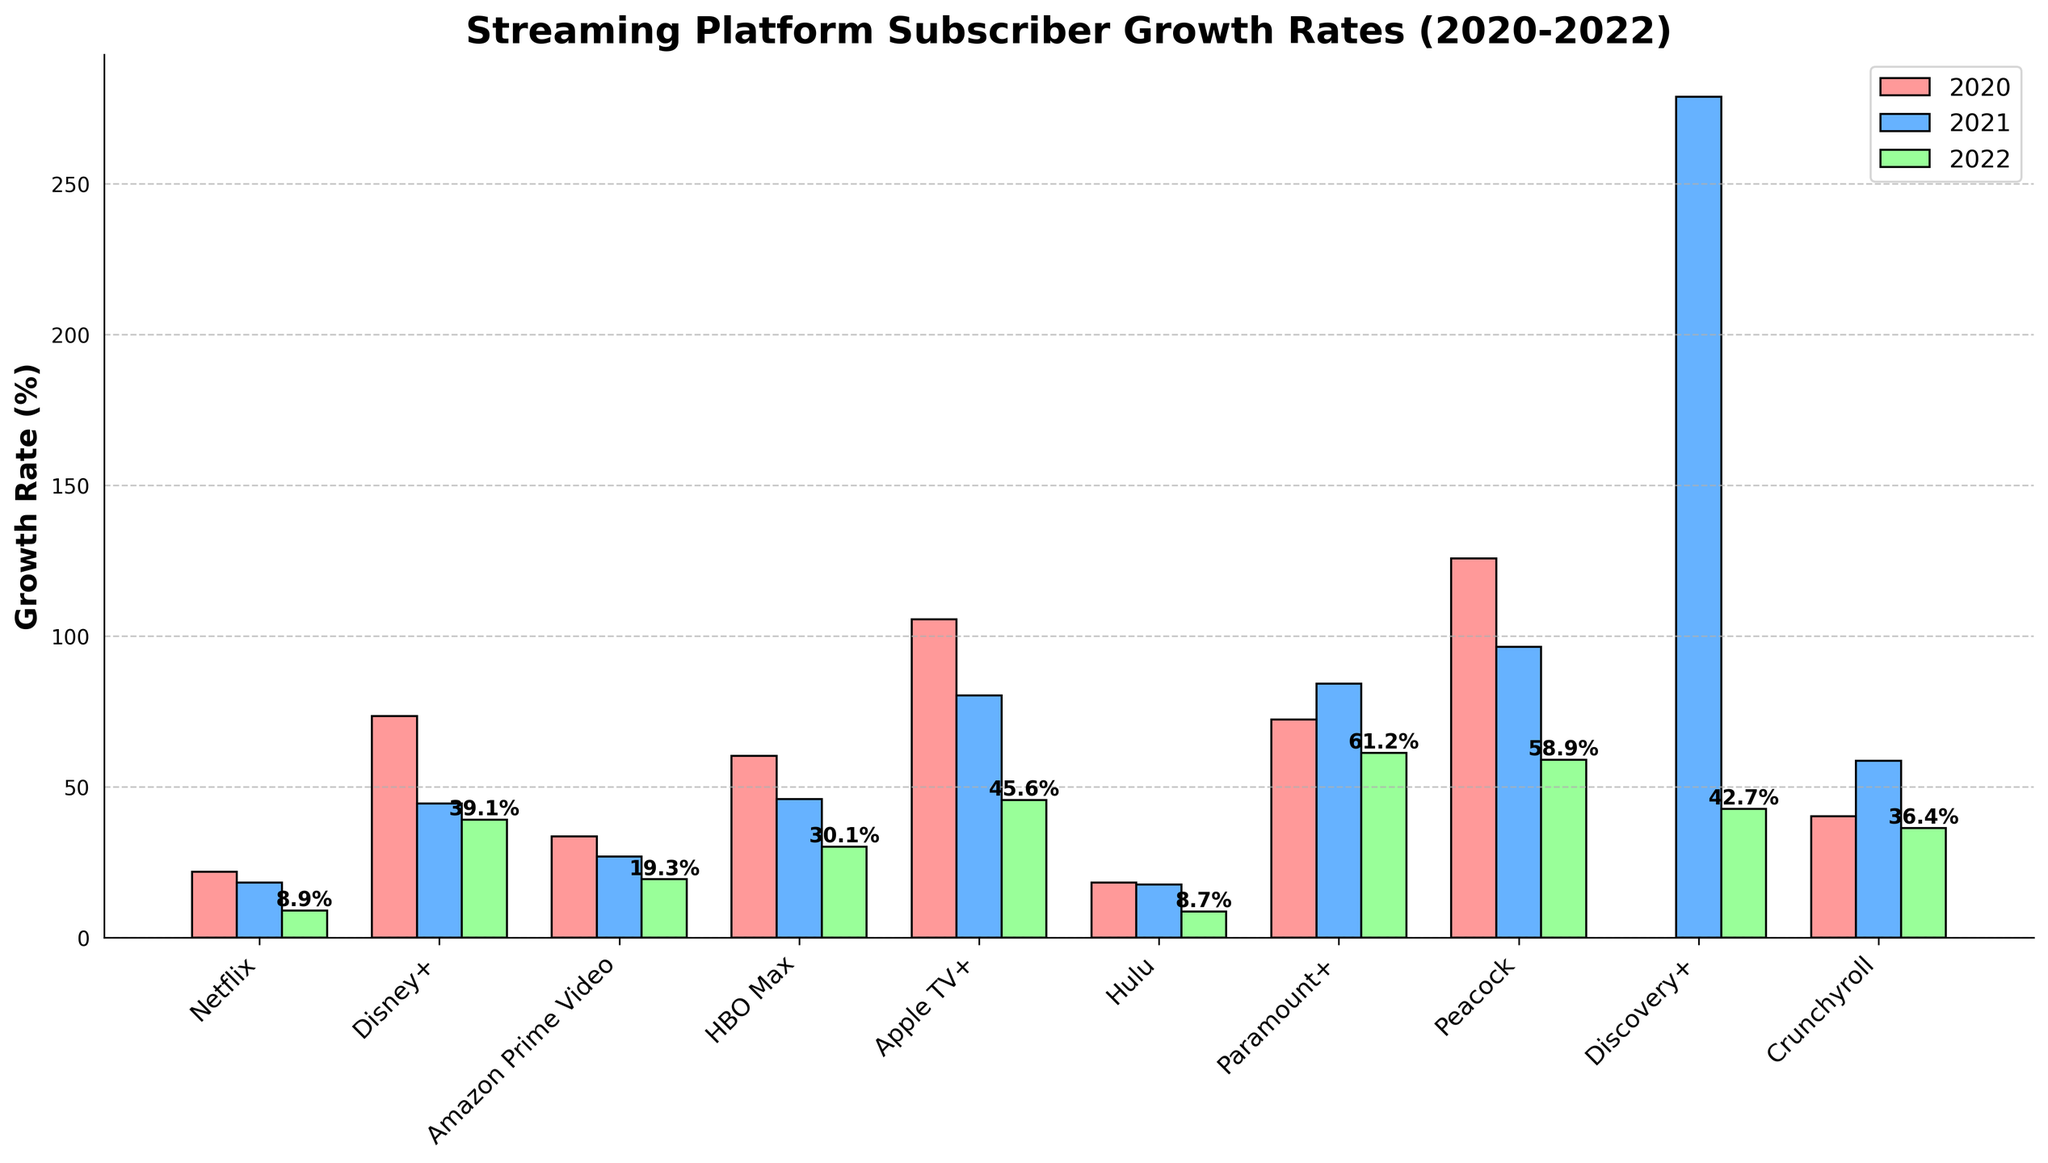What platform had the highest growth rate in 2021? Identify which bar representing the year 2021 (blue) is the tallest. In this case, Discovery+ had the highest growth rate in 2021 with a rate of 278.9%.
Answer: Discovery+ Which platform experienced the largest drop in growth rate from 2020 to 2022? Calculate the difference in growth rates from 2020 to 2022 for each platform and determine which has the largest negative difference. Peacock saw a significant drop from 125.8% in 2020 to 58.9% in 2022, a decrease of 66.9%.
Answer: Peacock How does the 2022 growth rate of Amazon Prime Video compare to Hulu? Identify and compare the heights of the bars in the green for Amazon Prime Video and Hulu in 2022. Amazon Prime Video had a growth rate of 19.3%, which is higher than Hulu’s 8.7%.
Answer: Amazon Prime Video is higher Which year did Paramount+ have the highest growth rate? Evaluate the growth rates for Paramount+ across the three years by comparing the heights of the bars. Paramount+ had the highest growth rate in 2021 at 84.3%.
Answer: 2021 Calculate the average growth rate of Netflix over the three years. Sum Netflix's growth rates for each year (21.9% + 18.2% + 8.9%) and divide by 3 to get the average. (21.9 + 18.2 + 8.9) / 3 = 16.33%.
Answer: 16.33% Which platform's 2022 growth rate is closest to its 2021 growth rate? Compare the bars for 2021 and 2022 for each platform to see which pair of bars has the smallest difference in height. Hulu's growth rates in 2021 and 2022 (17.6% and 8.7%) are the closest, with a difference of 8.9%.
Answer: Hulu Was there a platform that had a consistent declining growth rate from 2020 to 2022? Check each platform's growth rates across the years to see if their rates consistently declined. Netflix (21.9%, 18.2%, 8.9%) and Hulu (18.3%, 17.6%, 8.7%) both exhibit a consistent decline.
Answer: Netflix and Hulu How did Disney+'s growth rate change from 2021 to 2022? Subtract Disney+'s growth rate in 2022 from its growth rate in 2021 to see the change. 44.4% - 39.1% = 5.3%.
Answer: Decreased by 5.3% What is the combined growth rate of Apple TV+ over the three years? Sum the growth rates for Apple TV+ (105.6% + 80.3% + 45.6%) to get the combined growth rate. 105.6 + 80.3 + 45.6 = 231.5%.
Answer: 231.5% Identify the platform with the lowest 2022 growth rate. Compare the heights of the green bars representing 2022 growth rates and determine the shortest one. Hulu had the lowest growth rate in 2022 at 8.7%.
Answer: Hulu 